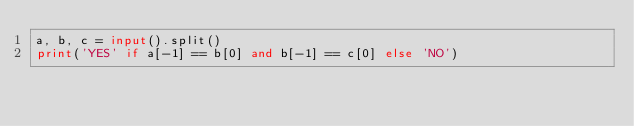Convert code to text. <code><loc_0><loc_0><loc_500><loc_500><_Python_>a, b, c = input().split()
print('YES' if a[-1] == b[0] and b[-1] == c[0] else 'NO')</code> 